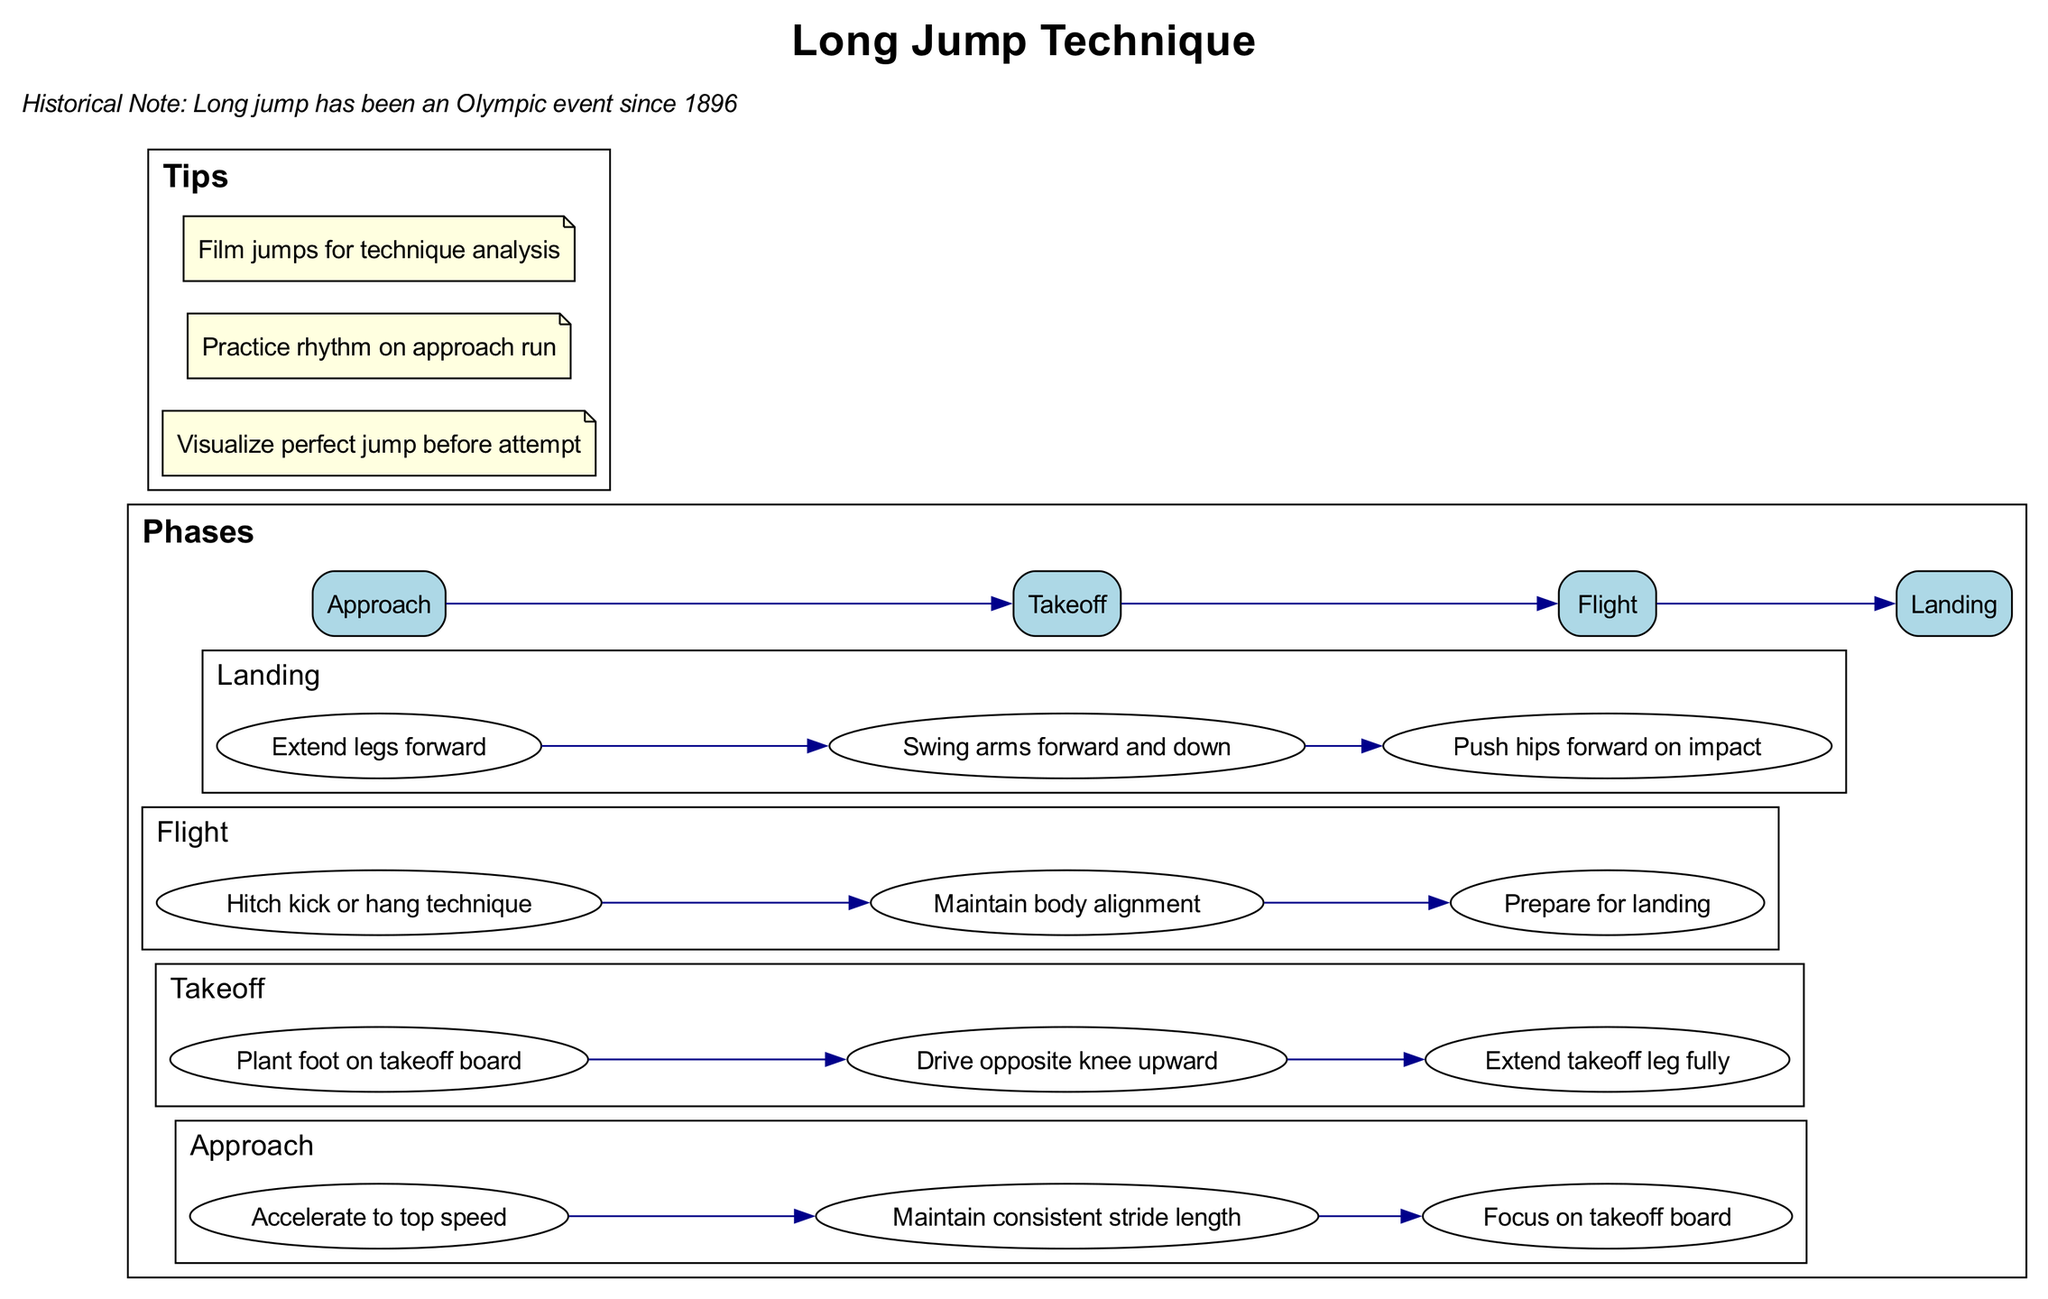What are the four phases of the long jump? The diagram lists four phases: Approach, Takeoff, Flight, and Landing.
Answer: Approach, Takeoff, Flight, Landing How many steps are there in the Takeoff phase? In the Takeoff phase, there are three steps provided: Plant foot on takeoff board, Drive opposite knee upward, and Extend takeoff leg fully.
Answer: Three What is the first step in the Approach phase? The first step in the Approach phase is "Accelerate to top speed." This directly follows from the order of the steps listed under the Approach phase section.
Answer: Accelerate to top speed Which phase includes "Extend legs forward" as a step? "Extend legs forward" is a step included in the Landing phase. By checking the steps listed in each phase, you can confirm this.
Answer: Landing What relationship exists between the Approach phase and the Takeoff phase? The Approach phase flows directly into the Takeoff phase, indicating a sequence where the completion of the Approach leads to the initiation of Takeoff.
Answer: Sequential flow How many total tips are there provided in the diagram? The diagram includes three tips, which can be verified by counting the tips listed in the Tips section of the diagram.
Answer: Three What technique is suggested in the Flight phase? The Flight phase suggests the "Hitch kick or hang technique" as part of maintaining optimal body position during flight. This is noted clearly under the Flight steps.
Answer: Hitch kick or hang technique What should a jumper do before making their attempt? The jumper should "Visualize perfect jump before attempt," as stated in the Tips section of the diagram.
Answer: Visualize perfect jump before attempt In what year did the long jump become an Olympic event? The historical note states that long jump has been an Olympic event since 1896, which is a specific piece of information explicitly provided in the diagram's historical context.
Answer: 1896 